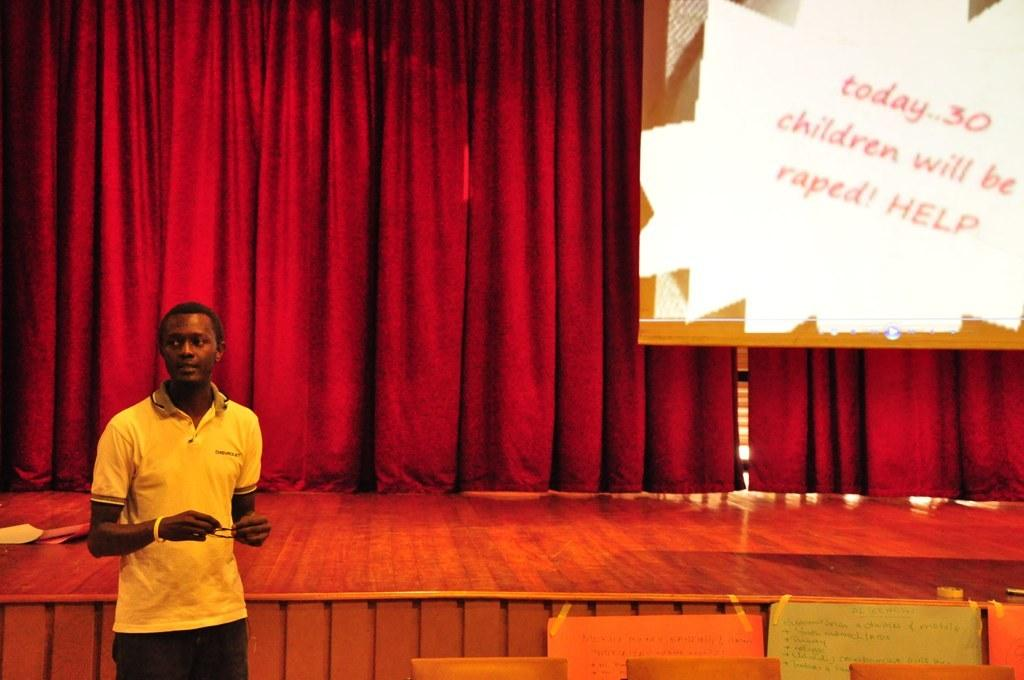Who is present on the left side of the image? There is a man standing on the left side of the image. What objects can be seen in the image? There are boards in the image. What is visible in the background of the image? There is a screen and curtains in the background of the image. What type of glass can be seen in the man's hand in the image? There is no glass present in the man's hand or in the image. 